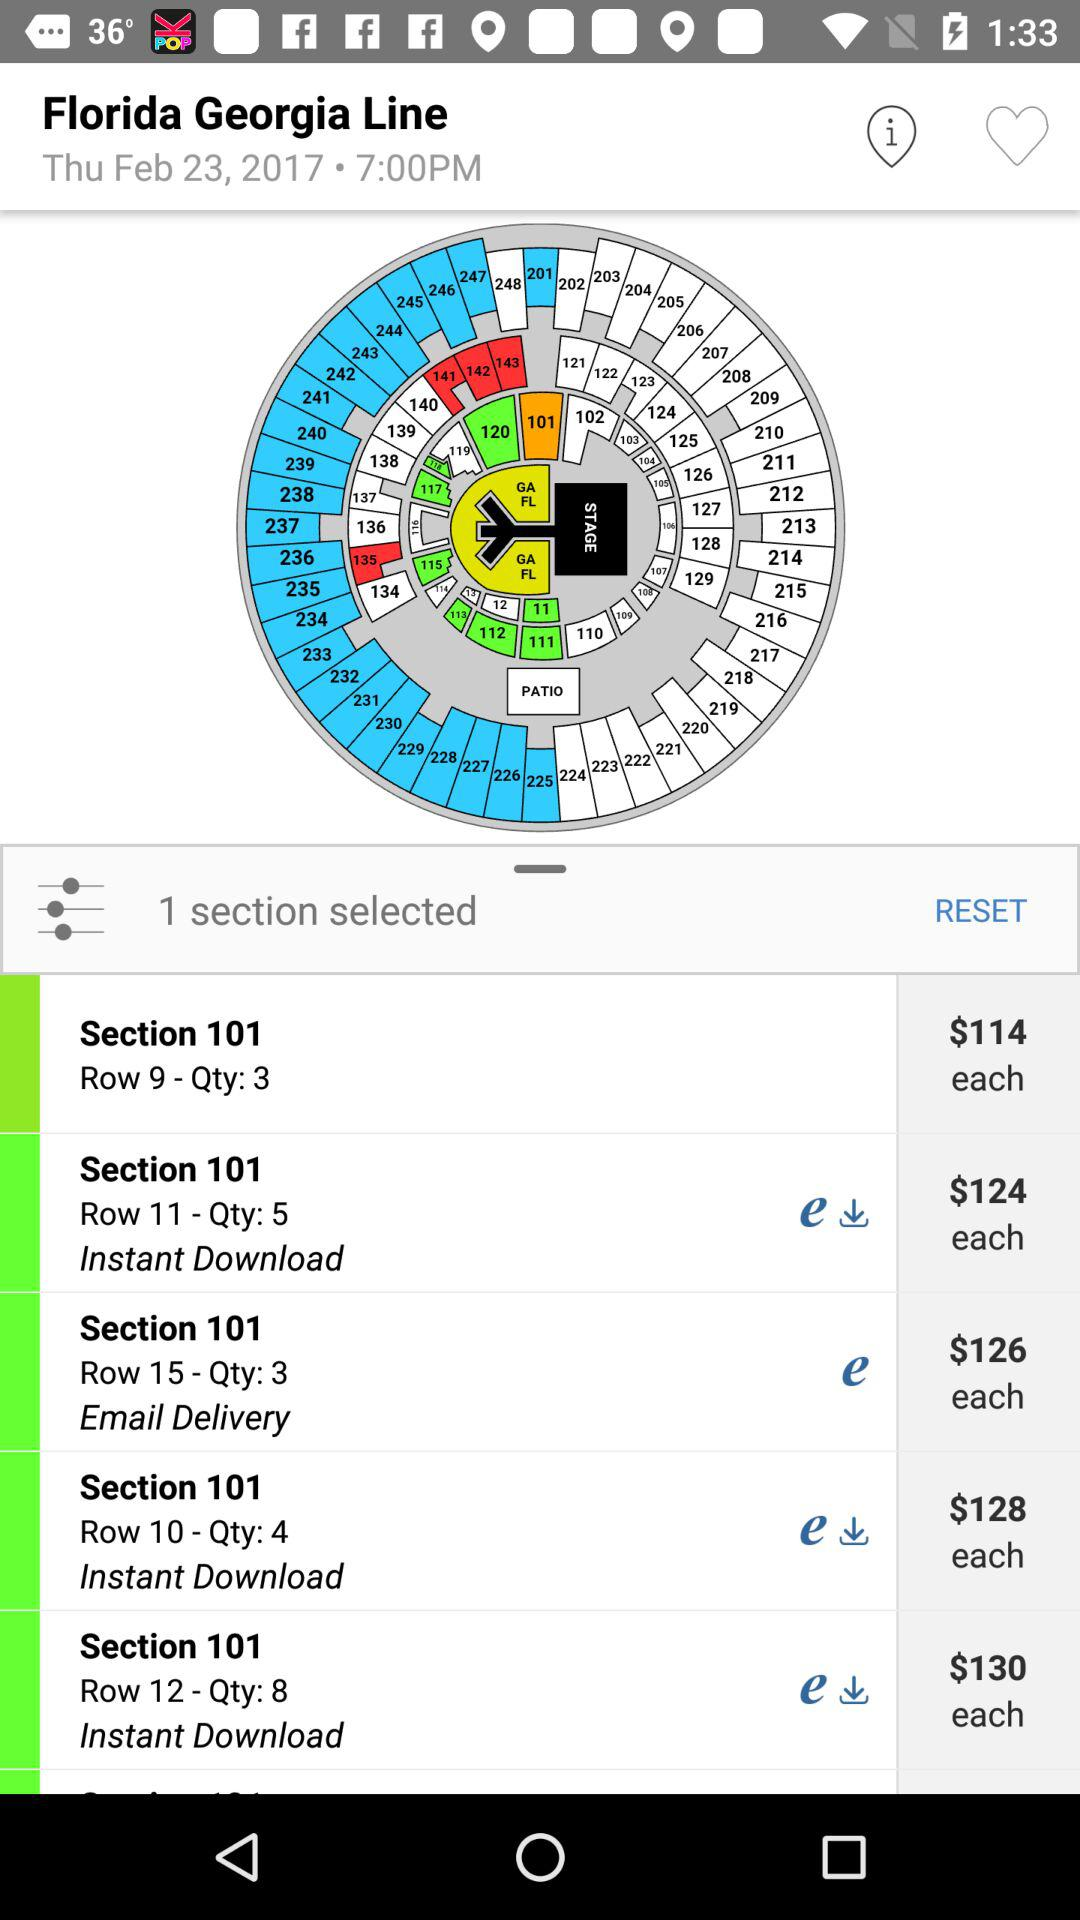What is the price of each item in row 12? The price is $130. 